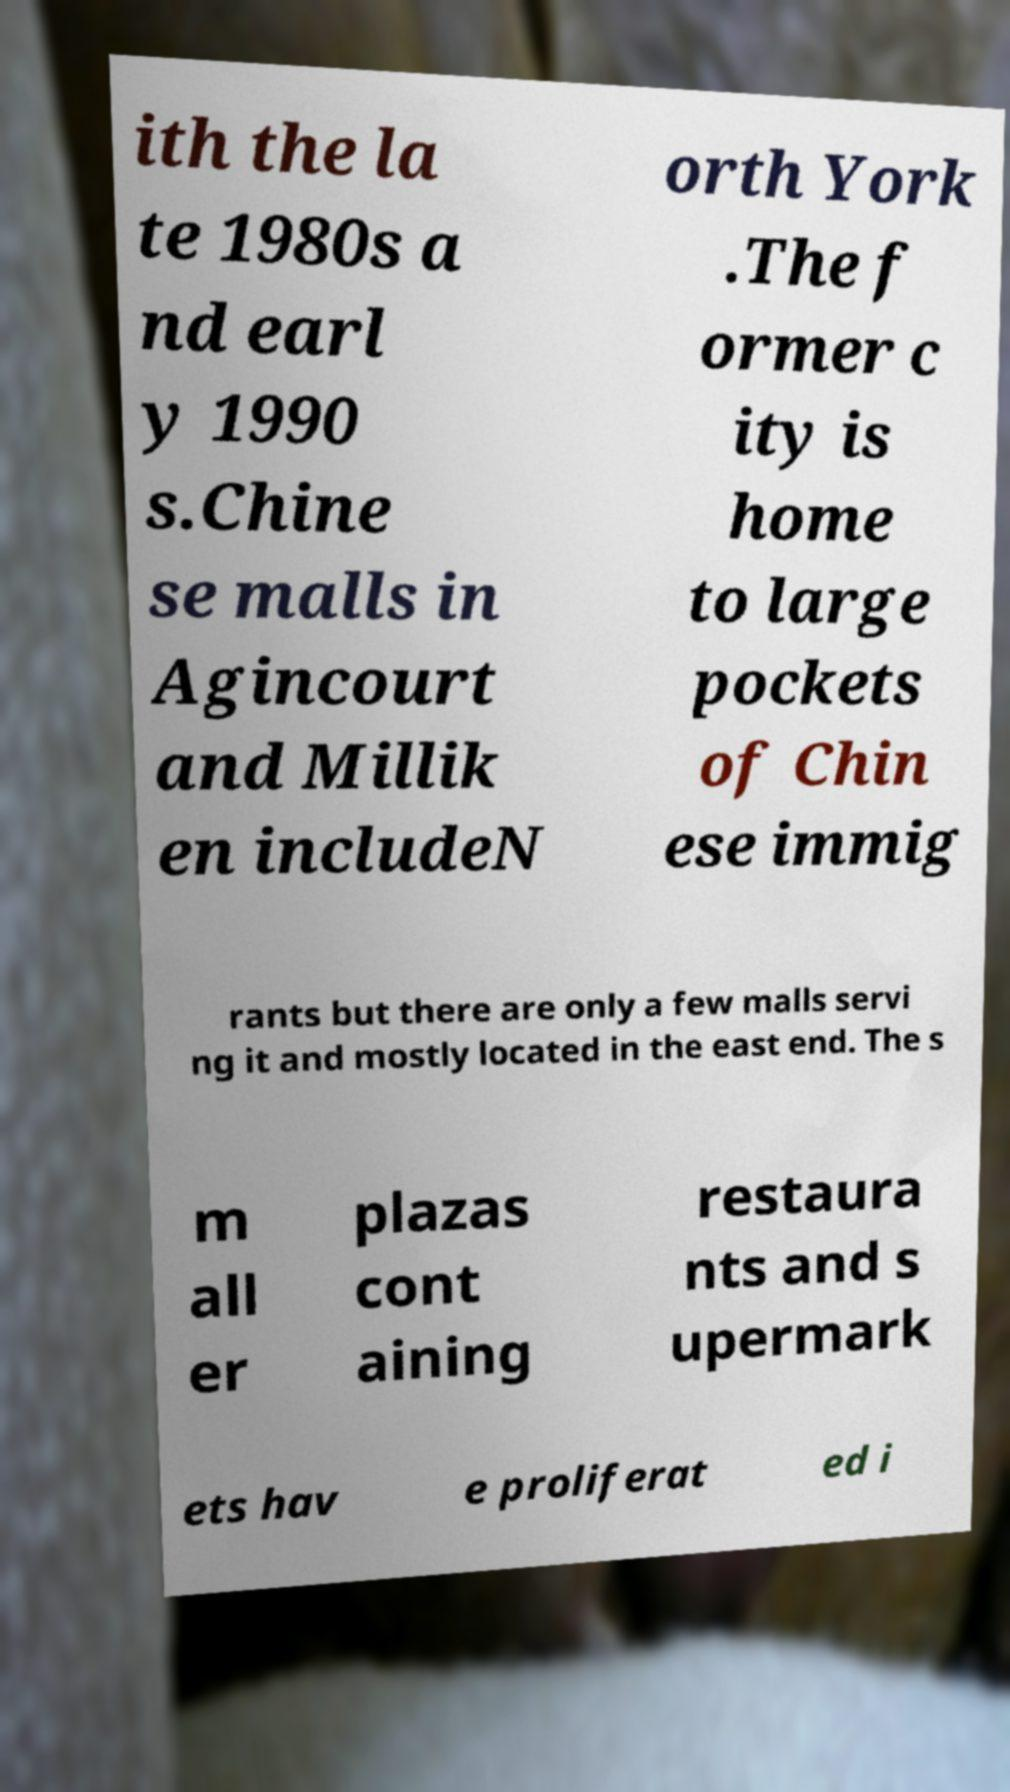For documentation purposes, I need the text within this image transcribed. Could you provide that? ith the la te 1980s a nd earl y 1990 s.Chine se malls in Agincourt and Millik en includeN orth York .The f ormer c ity is home to large pockets of Chin ese immig rants but there are only a few malls servi ng it and mostly located in the east end. The s m all er plazas cont aining restaura nts and s upermark ets hav e proliferat ed i 